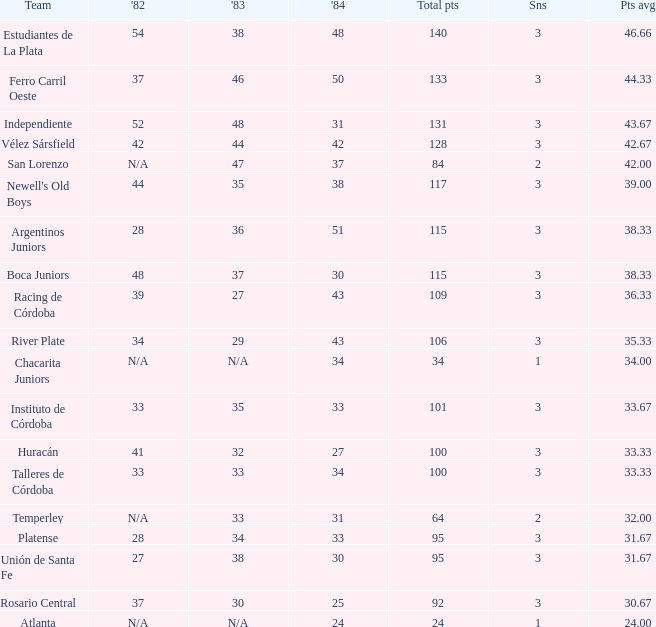What team had 3 seasons and fewer than 27 in 1984? Rosario Central. Would you mind parsing the complete table? {'header': ['Team', "'82", "'83", "'84", 'Total pts', 'Sns', 'Pts avg'], 'rows': [['Estudiantes de La Plata', '54', '38', '48', '140', '3', '46.66'], ['Ferro Carril Oeste', '37', '46', '50', '133', '3', '44.33'], ['Independiente', '52', '48', '31', '131', '3', '43.67'], ['Vélez Sársfield', '42', '44', '42', '128', '3', '42.67'], ['San Lorenzo', 'N/A', '47', '37', '84', '2', '42.00'], ["Newell's Old Boys", '44', '35', '38', '117', '3', '39.00'], ['Argentinos Juniors', '28', '36', '51', '115', '3', '38.33'], ['Boca Juniors', '48', '37', '30', '115', '3', '38.33'], ['Racing de Córdoba', '39', '27', '43', '109', '3', '36.33'], ['River Plate', '34', '29', '43', '106', '3', '35.33'], ['Chacarita Juniors', 'N/A', 'N/A', '34', '34', '1', '34.00'], ['Instituto de Córdoba', '33', '35', '33', '101', '3', '33.67'], ['Huracán', '41', '32', '27', '100', '3', '33.33'], ['Talleres de Córdoba', '33', '33', '34', '100', '3', '33.33'], ['Temperley', 'N/A', '33', '31', '64', '2', '32.00'], ['Platense', '28', '34', '33', '95', '3', '31.67'], ['Unión de Santa Fe', '27', '38', '30', '95', '3', '31.67'], ['Rosario Central', '37', '30', '25', '92', '3', '30.67'], ['Atlanta', 'N/A', 'N/A', '24', '24', '1', '24.00']]} 